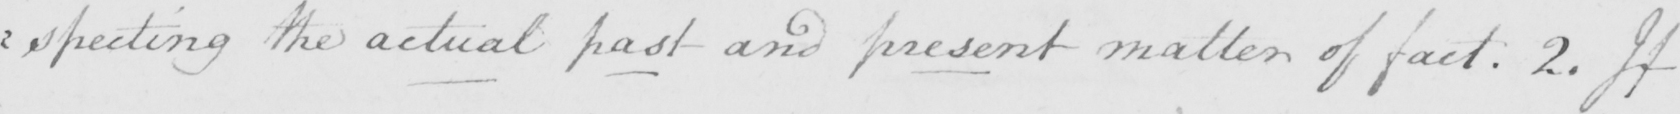Please transcribe the handwritten text in this image. : specting the actual past and present matter of fact . 2 . If 